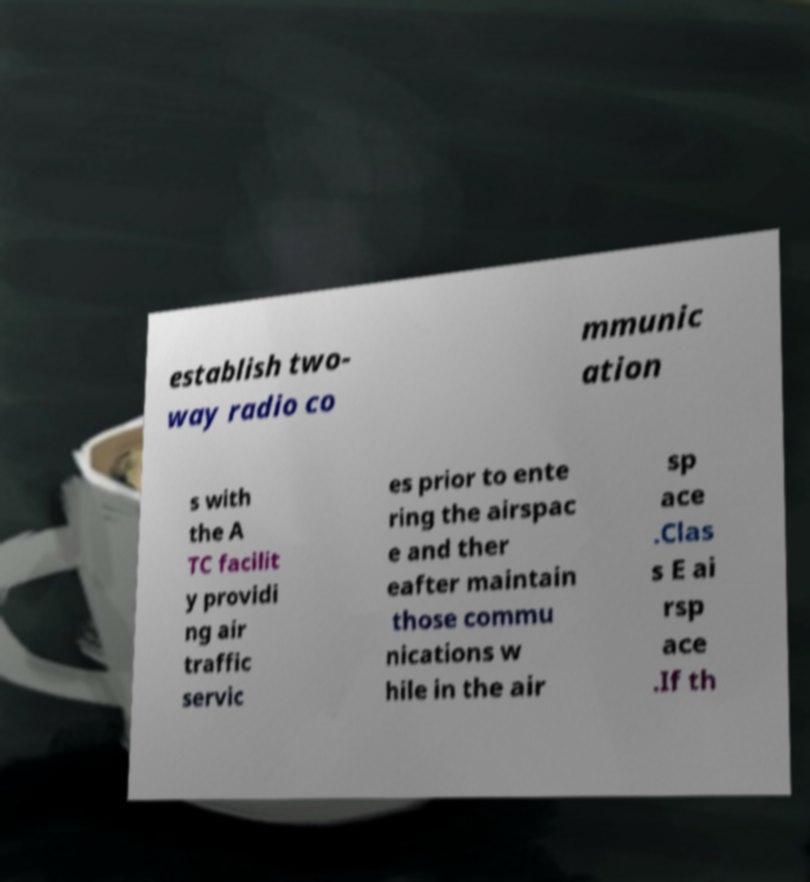Can you accurately transcribe the text from the provided image for me? establish two- way radio co mmunic ation s with the A TC facilit y providi ng air traffic servic es prior to ente ring the airspac e and ther eafter maintain those commu nications w hile in the air sp ace .Clas s E ai rsp ace .If th 